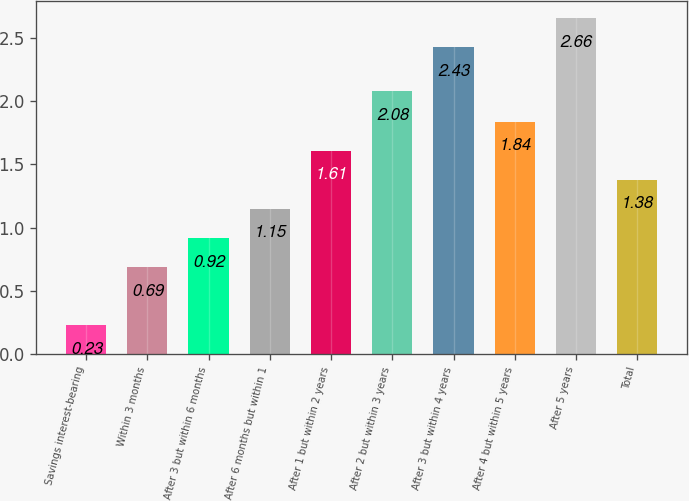Convert chart. <chart><loc_0><loc_0><loc_500><loc_500><bar_chart><fcel>Savings interest-bearing<fcel>Within 3 months<fcel>After 3 but within 6 months<fcel>After 6 months but within 1<fcel>After 1 but within 2 years<fcel>After 2 but within 3 years<fcel>After 3 but within 4 years<fcel>After 4 but within 5 years<fcel>After 5 years<fcel>Total<nl><fcel>0.23<fcel>0.69<fcel>0.92<fcel>1.15<fcel>1.61<fcel>2.08<fcel>2.43<fcel>1.84<fcel>2.66<fcel>1.38<nl></chart> 